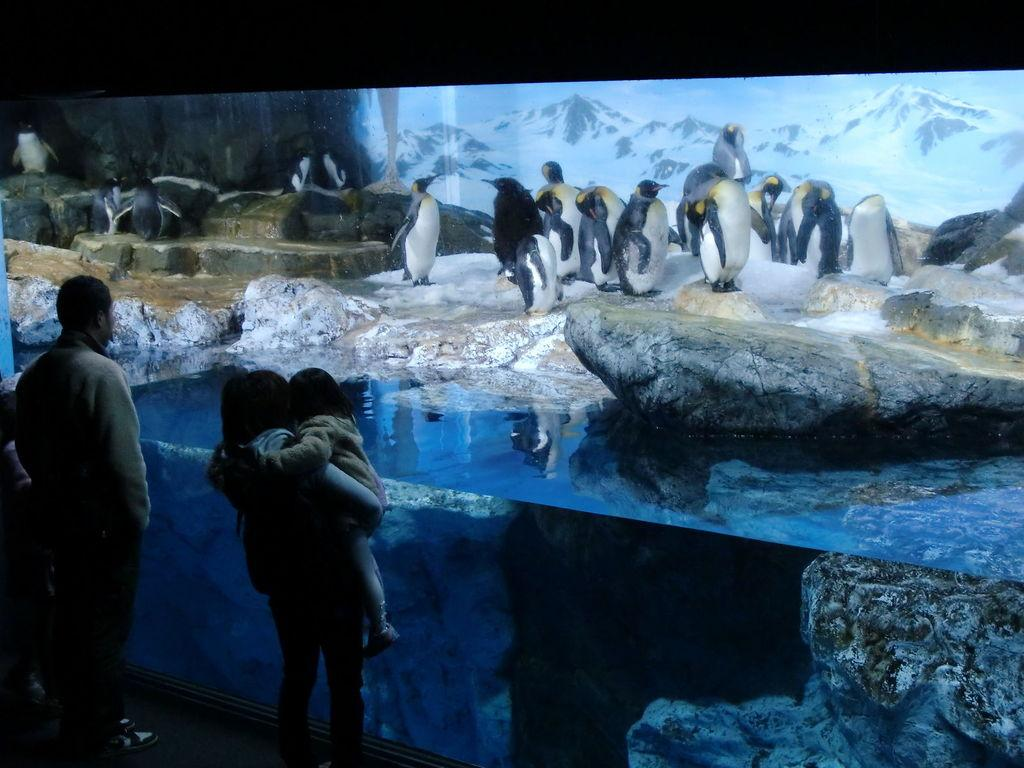What animals can be seen in the image? There are penguins on the ice in the image. What type of landscape is visible in the background? There are mountains visible in the background of the image. What is the rock in the image used for? The purpose of the rock in the image is not specified, but it could be a natural feature of the landscape. What is the water in the image used for? The water in the image could be used for drinking, bathing, or other purposes, but the specific use is not mentioned. What are the people in the image doing? There are people standing in the image, but their actions are not specified. What type of wristwatch is the penguin wearing in the image? There are no wristwatches visible in the image, as penguins do not wear accessories. 